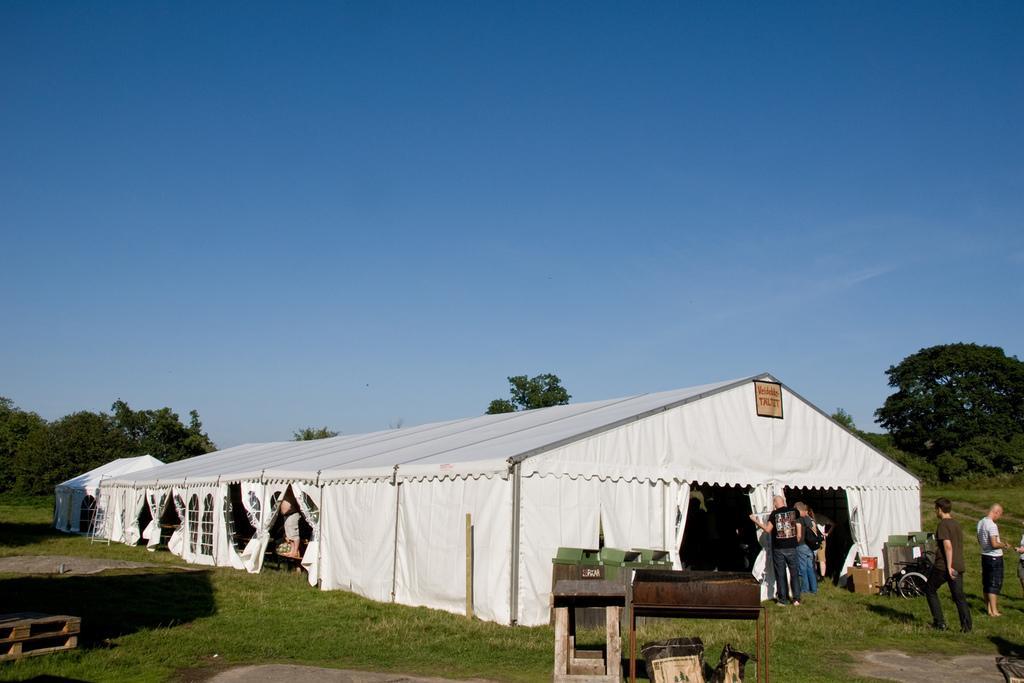Please provide a concise description of this image. In this picture there are tents and there are group of people standing and there is a person walking. There is a text on the tent and there are trees. In the foreground there is a table and there are objects and there are cardboard boxes and there are dustbins and there is a wheel chair at the tent. At the top there is sky. At the bottom there is grass and there is ground. 